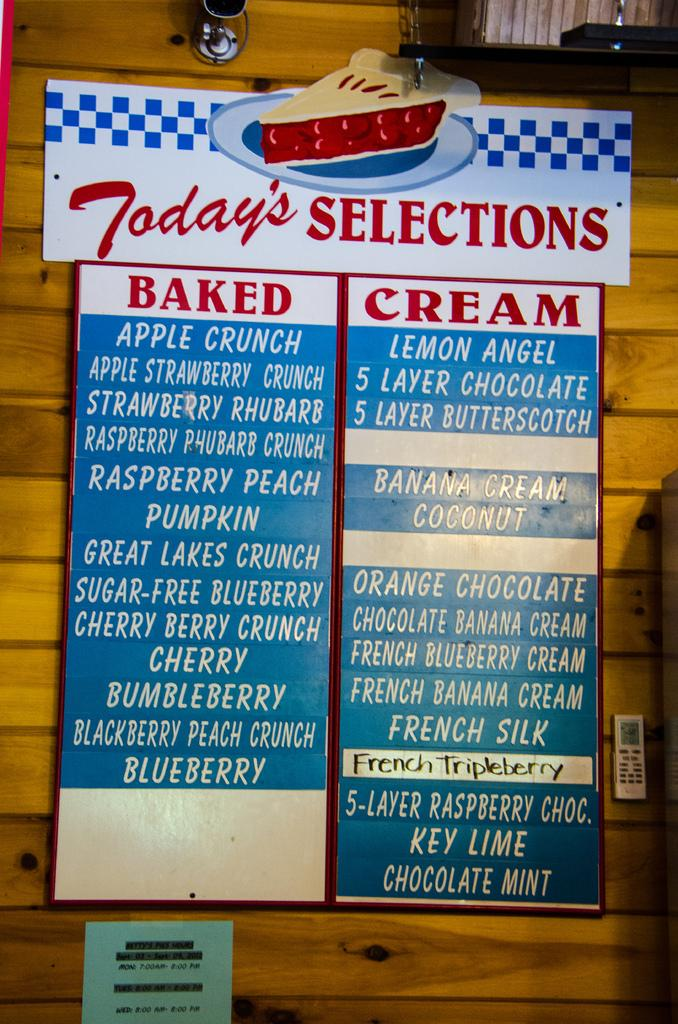Provide a one-sentence caption for the provided image. A long list of pies is under a sign that says "Today's Selections.". 